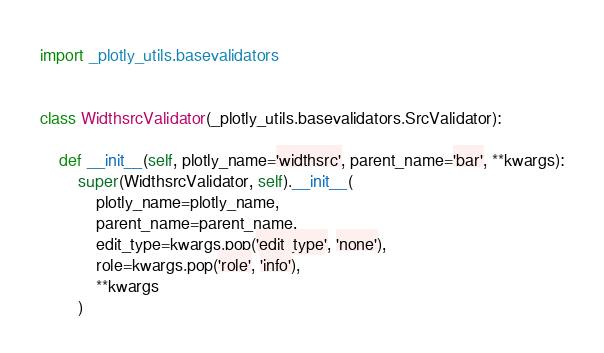Convert code to text. <code><loc_0><loc_0><loc_500><loc_500><_Python_>import _plotly_utils.basevalidators


class WidthsrcValidator(_plotly_utils.basevalidators.SrcValidator):

    def __init__(self, plotly_name='widthsrc', parent_name='bar', **kwargs):
        super(WidthsrcValidator, self).__init__(
            plotly_name=plotly_name,
            parent_name=parent_name,
            edit_type=kwargs.pop('edit_type', 'none'),
            role=kwargs.pop('role', 'info'),
            **kwargs
        )
</code> 